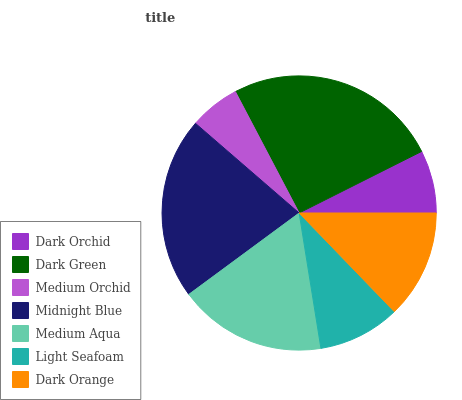Is Medium Orchid the minimum?
Answer yes or no. Yes. Is Dark Green the maximum?
Answer yes or no. Yes. Is Dark Green the minimum?
Answer yes or no. No. Is Medium Orchid the maximum?
Answer yes or no. No. Is Dark Green greater than Medium Orchid?
Answer yes or no. Yes. Is Medium Orchid less than Dark Green?
Answer yes or no. Yes. Is Medium Orchid greater than Dark Green?
Answer yes or no. No. Is Dark Green less than Medium Orchid?
Answer yes or no. No. Is Dark Orange the high median?
Answer yes or no. Yes. Is Dark Orange the low median?
Answer yes or no. Yes. Is Dark Green the high median?
Answer yes or no. No. Is Dark Orchid the low median?
Answer yes or no. No. 